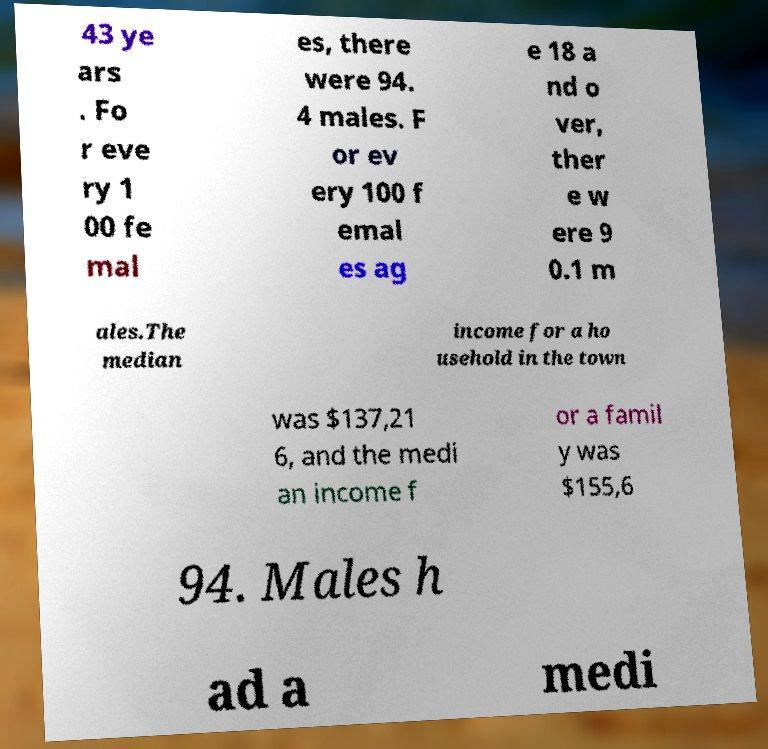I need the written content from this picture converted into text. Can you do that? 43 ye ars . Fo r eve ry 1 00 fe mal es, there were 94. 4 males. F or ev ery 100 f emal es ag e 18 a nd o ver, ther e w ere 9 0.1 m ales.The median income for a ho usehold in the town was $137,21 6, and the medi an income f or a famil y was $155,6 94. Males h ad a medi 